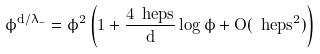Convert formula to latex. <formula><loc_0><loc_0><loc_500><loc_500>\phi ^ { d / \lambda _ { - } } = \phi ^ { 2 } \left ( 1 + \frac { 4 \ h e p s } { d } \log \phi + O ( \ h e p s ^ { 2 } ) \right )</formula> 